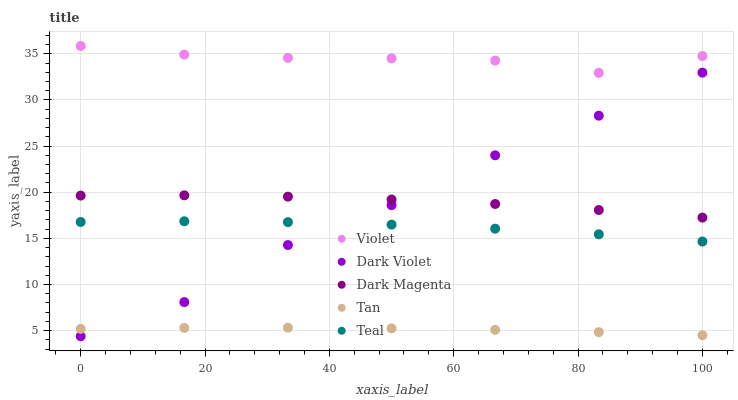Does Tan have the minimum area under the curve?
Answer yes or no. Yes. Does Violet have the maximum area under the curve?
Answer yes or no. Yes. Does Dark Magenta have the minimum area under the curve?
Answer yes or no. No. Does Dark Magenta have the maximum area under the curve?
Answer yes or no. No. Is Tan the smoothest?
Answer yes or no. Yes. Is Dark Violet the roughest?
Answer yes or no. Yes. Is Dark Magenta the smoothest?
Answer yes or no. No. Is Dark Magenta the roughest?
Answer yes or no. No. Does Dark Violet have the lowest value?
Answer yes or no. Yes. Does Tan have the lowest value?
Answer yes or no. No. Does Violet have the highest value?
Answer yes or no. Yes. Does Dark Magenta have the highest value?
Answer yes or no. No. Is Dark Magenta less than Violet?
Answer yes or no. Yes. Is Violet greater than Tan?
Answer yes or no. Yes. Does Teal intersect Dark Violet?
Answer yes or no. Yes. Is Teal less than Dark Violet?
Answer yes or no. No. Is Teal greater than Dark Violet?
Answer yes or no. No. Does Dark Magenta intersect Violet?
Answer yes or no. No. 